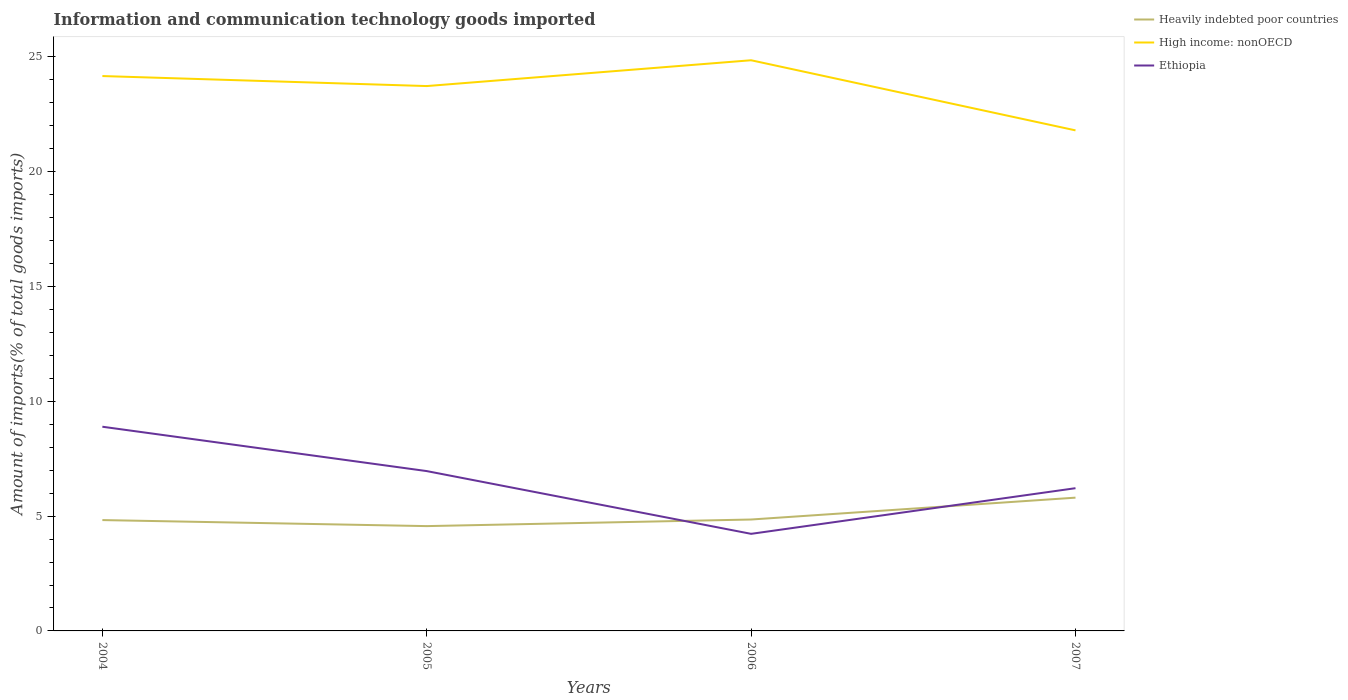How many different coloured lines are there?
Your response must be concise. 3. Does the line corresponding to Heavily indebted poor countries intersect with the line corresponding to High income: nonOECD?
Provide a succinct answer. No. Is the number of lines equal to the number of legend labels?
Ensure brevity in your answer.  Yes. Across all years, what is the maximum amount of goods imported in High income: nonOECD?
Ensure brevity in your answer.  21.8. In which year was the amount of goods imported in Heavily indebted poor countries maximum?
Provide a succinct answer. 2005. What is the total amount of goods imported in Ethiopia in the graph?
Offer a very short reply. 1.93. What is the difference between the highest and the second highest amount of goods imported in Ethiopia?
Offer a very short reply. 4.67. What is the difference between two consecutive major ticks on the Y-axis?
Provide a short and direct response. 5. Does the graph contain any zero values?
Ensure brevity in your answer.  No. Where does the legend appear in the graph?
Ensure brevity in your answer.  Top right. How many legend labels are there?
Your answer should be very brief. 3. How are the legend labels stacked?
Your answer should be compact. Vertical. What is the title of the graph?
Your answer should be compact. Information and communication technology goods imported. What is the label or title of the X-axis?
Your answer should be compact. Years. What is the label or title of the Y-axis?
Offer a terse response. Amount of imports(% of total goods imports). What is the Amount of imports(% of total goods imports) of Heavily indebted poor countries in 2004?
Provide a succinct answer. 4.83. What is the Amount of imports(% of total goods imports) of High income: nonOECD in 2004?
Your answer should be compact. 24.17. What is the Amount of imports(% of total goods imports) in Ethiopia in 2004?
Make the answer very short. 8.89. What is the Amount of imports(% of total goods imports) in Heavily indebted poor countries in 2005?
Your answer should be compact. 4.57. What is the Amount of imports(% of total goods imports) of High income: nonOECD in 2005?
Your response must be concise. 23.73. What is the Amount of imports(% of total goods imports) of Ethiopia in 2005?
Your answer should be compact. 6.96. What is the Amount of imports(% of total goods imports) in Heavily indebted poor countries in 2006?
Keep it short and to the point. 4.85. What is the Amount of imports(% of total goods imports) in High income: nonOECD in 2006?
Your answer should be compact. 24.86. What is the Amount of imports(% of total goods imports) of Ethiopia in 2006?
Keep it short and to the point. 4.23. What is the Amount of imports(% of total goods imports) in Heavily indebted poor countries in 2007?
Provide a succinct answer. 5.81. What is the Amount of imports(% of total goods imports) in High income: nonOECD in 2007?
Provide a short and direct response. 21.8. What is the Amount of imports(% of total goods imports) of Ethiopia in 2007?
Ensure brevity in your answer.  6.22. Across all years, what is the maximum Amount of imports(% of total goods imports) in Heavily indebted poor countries?
Your response must be concise. 5.81. Across all years, what is the maximum Amount of imports(% of total goods imports) of High income: nonOECD?
Ensure brevity in your answer.  24.86. Across all years, what is the maximum Amount of imports(% of total goods imports) of Ethiopia?
Keep it short and to the point. 8.89. Across all years, what is the minimum Amount of imports(% of total goods imports) of Heavily indebted poor countries?
Provide a short and direct response. 4.57. Across all years, what is the minimum Amount of imports(% of total goods imports) in High income: nonOECD?
Give a very brief answer. 21.8. Across all years, what is the minimum Amount of imports(% of total goods imports) of Ethiopia?
Give a very brief answer. 4.23. What is the total Amount of imports(% of total goods imports) in Heavily indebted poor countries in the graph?
Ensure brevity in your answer.  20.05. What is the total Amount of imports(% of total goods imports) in High income: nonOECD in the graph?
Keep it short and to the point. 94.56. What is the total Amount of imports(% of total goods imports) of Ethiopia in the graph?
Ensure brevity in your answer.  26.3. What is the difference between the Amount of imports(% of total goods imports) of Heavily indebted poor countries in 2004 and that in 2005?
Make the answer very short. 0.26. What is the difference between the Amount of imports(% of total goods imports) of High income: nonOECD in 2004 and that in 2005?
Keep it short and to the point. 0.44. What is the difference between the Amount of imports(% of total goods imports) of Ethiopia in 2004 and that in 2005?
Provide a short and direct response. 1.93. What is the difference between the Amount of imports(% of total goods imports) in Heavily indebted poor countries in 2004 and that in 2006?
Offer a terse response. -0.02. What is the difference between the Amount of imports(% of total goods imports) of High income: nonOECD in 2004 and that in 2006?
Your response must be concise. -0.69. What is the difference between the Amount of imports(% of total goods imports) in Ethiopia in 2004 and that in 2006?
Give a very brief answer. 4.67. What is the difference between the Amount of imports(% of total goods imports) of Heavily indebted poor countries in 2004 and that in 2007?
Ensure brevity in your answer.  -0.98. What is the difference between the Amount of imports(% of total goods imports) of High income: nonOECD in 2004 and that in 2007?
Make the answer very short. 2.37. What is the difference between the Amount of imports(% of total goods imports) in Ethiopia in 2004 and that in 2007?
Your answer should be compact. 2.68. What is the difference between the Amount of imports(% of total goods imports) of Heavily indebted poor countries in 2005 and that in 2006?
Provide a short and direct response. -0.29. What is the difference between the Amount of imports(% of total goods imports) of High income: nonOECD in 2005 and that in 2006?
Keep it short and to the point. -1.12. What is the difference between the Amount of imports(% of total goods imports) in Ethiopia in 2005 and that in 2006?
Ensure brevity in your answer.  2.73. What is the difference between the Amount of imports(% of total goods imports) of Heavily indebted poor countries in 2005 and that in 2007?
Offer a terse response. -1.24. What is the difference between the Amount of imports(% of total goods imports) in High income: nonOECD in 2005 and that in 2007?
Give a very brief answer. 1.93. What is the difference between the Amount of imports(% of total goods imports) of Ethiopia in 2005 and that in 2007?
Provide a succinct answer. 0.74. What is the difference between the Amount of imports(% of total goods imports) in Heavily indebted poor countries in 2006 and that in 2007?
Your response must be concise. -0.95. What is the difference between the Amount of imports(% of total goods imports) of High income: nonOECD in 2006 and that in 2007?
Make the answer very short. 3.05. What is the difference between the Amount of imports(% of total goods imports) in Ethiopia in 2006 and that in 2007?
Make the answer very short. -1.99. What is the difference between the Amount of imports(% of total goods imports) in Heavily indebted poor countries in 2004 and the Amount of imports(% of total goods imports) in High income: nonOECD in 2005?
Offer a very short reply. -18.9. What is the difference between the Amount of imports(% of total goods imports) of Heavily indebted poor countries in 2004 and the Amount of imports(% of total goods imports) of Ethiopia in 2005?
Make the answer very short. -2.13. What is the difference between the Amount of imports(% of total goods imports) in High income: nonOECD in 2004 and the Amount of imports(% of total goods imports) in Ethiopia in 2005?
Offer a terse response. 17.21. What is the difference between the Amount of imports(% of total goods imports) of Heavily indebted poor countries in 2004 and the Amount of imports(% of total goods imports) of High income: nonOECD in 2006?
Your answer should be very brief. -20.03. What is the difference between the Amount of imports(% of total goods imports) of Heavily indebted poor countries in 2004 and the Amount of imports(% of total goods imports) of Ethiopia in 2006?
Provide a short and direct response. 0.6. What is the difference between the Amount of imports(% of total goods imports) in High income: nonOECD in 2004 and the Amount of imports(% of total goods imports) in Ethiopia in 2006?
Your answer should be very brief. 19.94. What is the difference between the Amount of imports(% of total goods imports) in Heavily indebted poor countries in 2004 and the Amount of imports(% of total goods imports) in High income: nonOECD in 2007?
Ensure brevity in your answer.  -16.98. What is the difference between the Amount of imports(% of total goods imports) in Heavily indebted poor countries in 2004 and the Amount of imports(% of total goods imports) in Ethiopia in 2007?
Give a very brief answer. -1.39. What is the difference between the Amount of imports(% of total goods imports) of High income: nonOECD in 2004 and the Amount of imports(% of total goods imports) of Ethiopia in 2007?
Your response must be concise. 17.95. What is the difference between the Amount of imports(% of total goods imports) in Heavily indebted poor countries in 2005 and the Amount of imports(% of total goods imports) in High income: nonOECD in 2006?
Offer a very short reply. -20.29. What is the difference between the Amount of imports(% of total goods imports) of Heavily indebted poor countries in 2005 and the Amount of imports(% of total goods imports) of Ethiopia in 2006?
Provide a succinct answer. 0.34. What is the difference between the Amount of imports(% of total goods imports) of High income: nonOECD in 2005 and the Amount of imports(% of total goods imports) of Ethiopia in 2006?
Your response must be concise. 19.5. What is the difference between the Amount of imports(% of total goods imports) of Heavily indebted poor countries in 2005 and the Amount of imports(% of total goods imports) of High income: nonOECD in 2007?
Your answer should be very brief. -17.24. What is the difference between the Amount of imports(% of total goods imports) of Heavily indebted poor countries in 2005 and the Amount of imports(% of total goods imports) of Ethiopia in 2007?
Your answer should be compact. -1.65. What is the difference between the Amount of imports(% of total goods imports) of High income: nonOECD in 2005 and the Amount of imports(% of total goods imports) of Ethiopia in 2007?
Your answer should be very brief. 17.52. What is the difference between the Amount of imports(% of total goods imports) in Heavily indebted poor countries in 2006 and the Amount of imports(% of total goods imports) in High income: nonOECD in 2007?
Give a very brief answer. -16.95. What is the difference between the Amount of imports(% of total goods imports) in Heavily indebted poor countries in 2006 and the Amount of imports(% of total goods imports) in Ethiopia in 2007?
Keep it short and to the point. -1.36. What is the difference between the Amount of imports(% of total goods imports) of High income: nonOECD in 2006 and the Amount of imports(% of total goods imports) of Ethiopia in 2007?
Offer a terse response. 18.64. What is the average Amount of imports(% of total goods imports) in Heavily indebted poor countries per year?
Give a very brief answer. 5.01. What is the average Amount of imports(% of total goods imports) in High income: nonOECD per year?
Your answer should be compact. 23.64. What is the average Amount of imports(% of total goods imports) of Ethiopia per year?
Ensure brevity in your answer.  6.58. In the year 2004, what is the difference between the Amount of imports(% of total goods imports) in Heavily indebted poor countries and Amount of imports(% of total goods imports) in High income: nonOECD?
Ensure brevity in your answer.  -19.34. In the year 2004, what is the difference between the Amount of imports(% of total goods imports) in Heavily indebted poor countries and Amount of imports(% of total goods imports) in Ethiopia?
Offer a very short reply. -4.07. In the year 2004, what is the difference between the Amount of imports(% of total goods imports) of High income: nonOECD and Amount of imports(% of total goods imports) of Ethiopia?
Offer a terse response. 15.28. In the year 2005, what is the difference between the Amount of imports(% of total goods imports) in Heavily indebted poor countries and Amount of imports(% of total goods imports) in High income: nonOECD?
Offer a very short reply. -19.17. In the year 2005, what is the difference between the Amount of imports(% of total goods imports) of Heavily indebted poor countries and Amount of imports(% of total goods imports) of Ethiopia?
Your response must be concise. -2.4. In the year 2005, what is the difference between the Amount of imports(% of total goods imports) of High income: nonOECD and Amount of imports(% of total goods imports) of Ethiopia?
Make the answer very short. 16.77. In the year 2006, what is the difference between the Amount of imports(% of total goods imports) of Heavily indebted poor countries and Amount of imports(% of total goods imports) of High income: nonOECD?
Make the answer very short. -20. In the year 2006, what is the difference between the Amount of imports(% of total goods imports) of Heavily indebted poor countries and Amount of imports(% of total goods imports) of Ethiopia?
Keep it short and to the point. 0.62. In the year 2006, what is the difference between the Amount of imports(% of total goods imports) in High income: nonOECD and Amount of imports(% of total goods imports) in Ethiopia?
Provide a short and direct response. 20.63. In the year 2007, what is the difference between the Amount of imports(% of total goods imports) of Heavily indebted poor countries and Amount of imports(% of total goods imports) of High income: nonOECD?
Your answer should be compact. -16. In the year 2007, what is the difference between the Amount of imports(% of total goods imports) in Heavily indebted poor countries and Amount of imports(% of total goods imports) in Ethiopia?
Give a very brief answer. -0.41. In the year 2007, what is the difference between the Amount of imports(% of total goods imports) in High income: nonOECD and Amount of imports(% of total goods imports) in Ethiopia?
Provide a short and direct response. 15.59. What is the ratio of the Amount of imports(% of total goods imports) in Heavily indebted poor countries in 2004 to that in 2005?
Offer a terse response. 1.06. What is the ratio of the Amount of imports(% of total goods imports) in High income: nonOECD in 2004 to that in 2005?
Offer a very short reply. 1.02. What is the ratio of the Amount of imports(% of total goods imports) of Ethiopia in 2004 to that in 2005?
Your answer should be very brief. 1.28. What is the ratio of the Amount of imports(% of total goods imports) in High income: nonOECD in 2004 to that in 2006?
Make the answer very short. 0.97. What is the ratio of the Amount of imports(% of total goods imports) in Ethiopia in 2004 to that in 2006?
Your response must be concise. 2.1. What is the ratio of the Amount of imports(% of total goods imports) in Heavily indebted poor countries in 2004 to that in 2007?
Ensure brevity in your answer.  0.83. What is the ratio of the Amount of imports(% of total goods imports) in High income: nonOECD in 2004 to that in 2007?
Offer a terse response. 1.11. What is the ratio of the Amount of imports(% of total goods imports) of Ethiopia in 2004 to that in 2007?
Your answer should be very brief. 1.43. What is the ratio of the Amount of imports(% of total goods imports) of Heavily indebted poor countries in 2005 to that in 2006?
Your response must be concise. 0.94. What is the ratio of the Amount of imports(% of total goods imports) of High income: nonOECD in 2005 to that in 2006?
Offer a very short reply. 0.95. What is the ratio of the Amount of imports(% of total goods imports) of Ethiopia in 2005 to that in 2006?
Your answer should be very brief. 1.65. What is the ratio of the Amount of imports(% of total goods imports) of Heavily indebted poor countries in 2005 to that in 2007?
Provide a short and direct response. 0.79. What is the ratio of the Amount of imports(% of total goods imports) in High income: nonOECD in 2005 to that in 2007?
Provide a short and direct response. 1.09. What is the ratio of the Amount of imports(% of total goods imports) of Ethiopia in 2005 to that in 2007?
Your response must be concise. 1.12. What is the ratio of the Amount of imports(% of total goods imports) in Heavily indebted poor countries in 2006 to that in 2007?
Your answer should be compact. 0.84. What is the ratio of the Amount of imports(% of total goods imports) of High income: nonOECD in 2006 to that in 2007?
Make the answer very short. 1.14. What is the ratio of the Amount of imports(% of total goods imports) in Ethiopia in 2006 to that in 2007?
Make the answer very short. 0.68. What is the difference between the highest and the second highest Amount of imports(% of total goods imports) of Heavily indebted poor countries?
Provide a short and direct response. 0.95. What is the difference between the highest and the second highest Amount of imports(% of total goods imports) of High income: nonOECD?
Your response must be concise. 0.69. What is the difference between the highest and the second highest Amount of imports(% of total goods imports) in Ethiopia?
Keep it short and to the point. 1.93. What is the difference between the highest and the lowest Amount of imports(% of total goods imports) in Heavily indebted poor countries?
Give a very brief answer. 1.24. What is the difference between the highest and the lowest Amount of imports(% of total goods imports) in High income: nonOECD?
Give a very brief answer. 3.05. What is the difference between the highest and the lowest Amount of imports(% of total goods imports) in Ethiopia?
Ensure brevity in your answer.  4.67. 